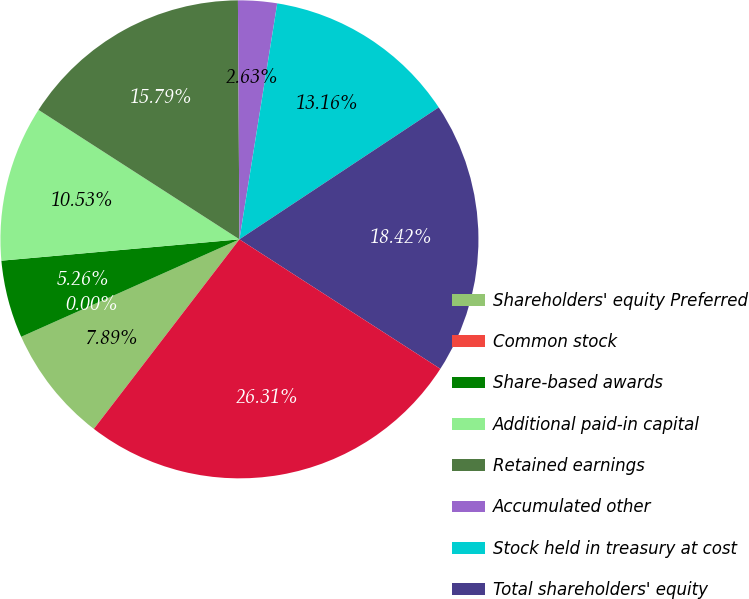<chart> <loc_0><loc_0><loc_500><loc_500><pie_chart><fcel>Shareholders' equity Preferred<fcel>Common stock<fcel>Share-based awards<fcel>Additional paid-in capital<fcel>Retained earnings<fcel>Accumulated other<fcel>Stock held in treasury at cost<fcel>Total shareholders' equity<fcel>Total liabilities and<nl><fcel>7.89%<fcel>0.0%<fcel>5.26%<fcel>10.53%<fcel>15.79%<fcel>2.63%<fcel>13.16%<fcel>18.42%<fcel>26.31%<nl></chart> 